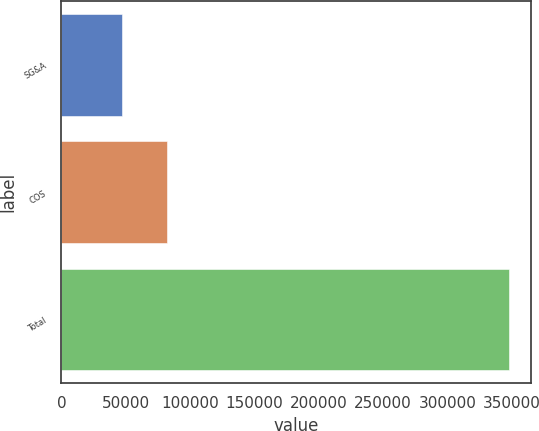Convert chart to OTSL. <chart><loc_0><loc_0><loc_500><loc_500><bar_chart><fcel>SG&A<fcel>COS<fcel>Total<nl><fcel>46682<fcel>82210<fcel>347777<nl></chart> 